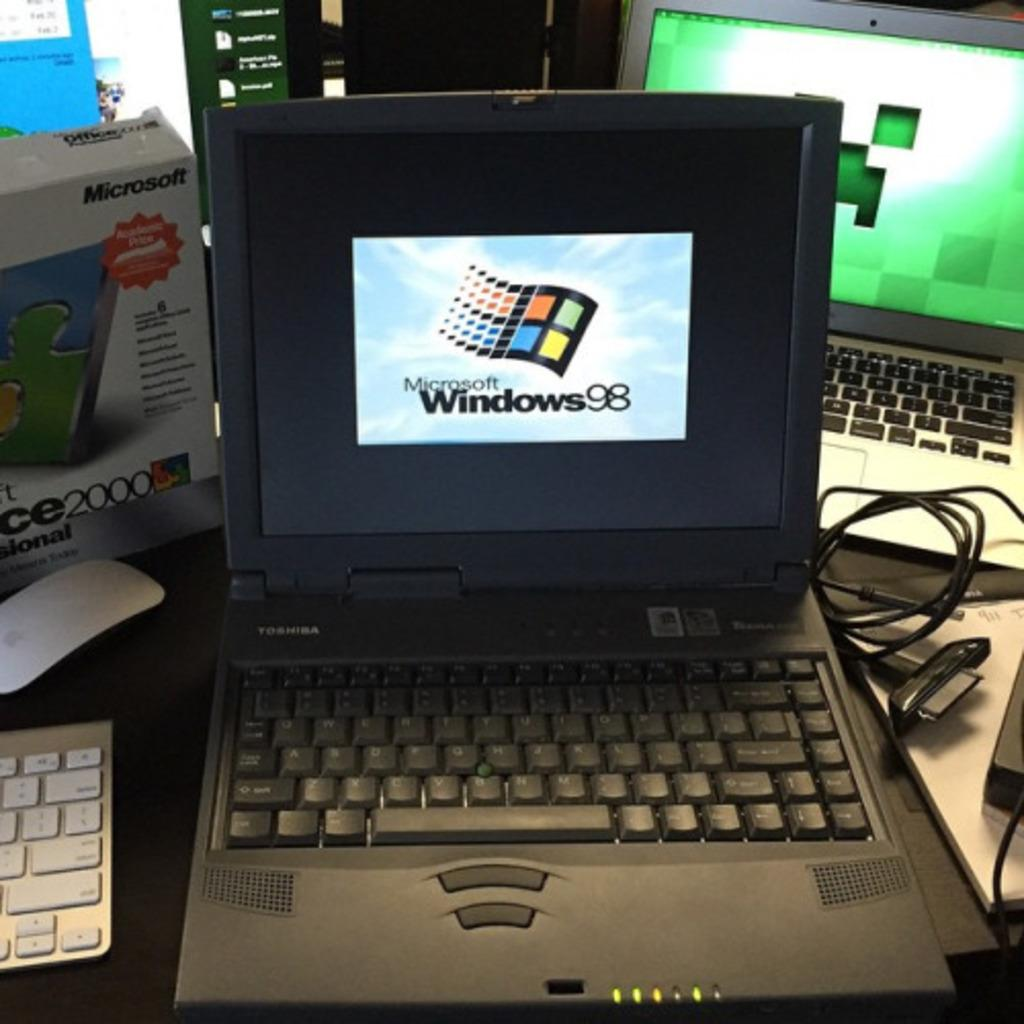<image>
Relay a brief, clear account of the picture shown. The laptop Toshiba screen shows the windows 98 logo on it. 